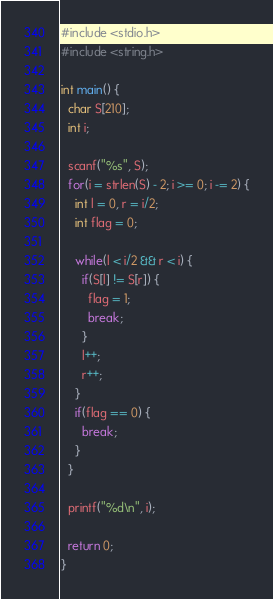Convert code to text. <code><loc_0><loc_0><loc_500><loc_500><_C_>#include <stdio.h>
#include <string.h>

int main() {
  char S[210];
  int i;
  
  scanf("%s", S);
  for(i = strlen(S) - 2; i >= 0; i -= 2) {
    int l = 0, r = i/2;
    int flag = 0;
    
    while(l < i/2 && r < i) {
      if(S[l] != S[r]) {
        flag = 1;
        break;
      }
      l++;
      r++;
    }
    if(flag == 0) {
      break;
    }
  }
  
  printf("%d\n", i);
  
  return 0;
}</code> 